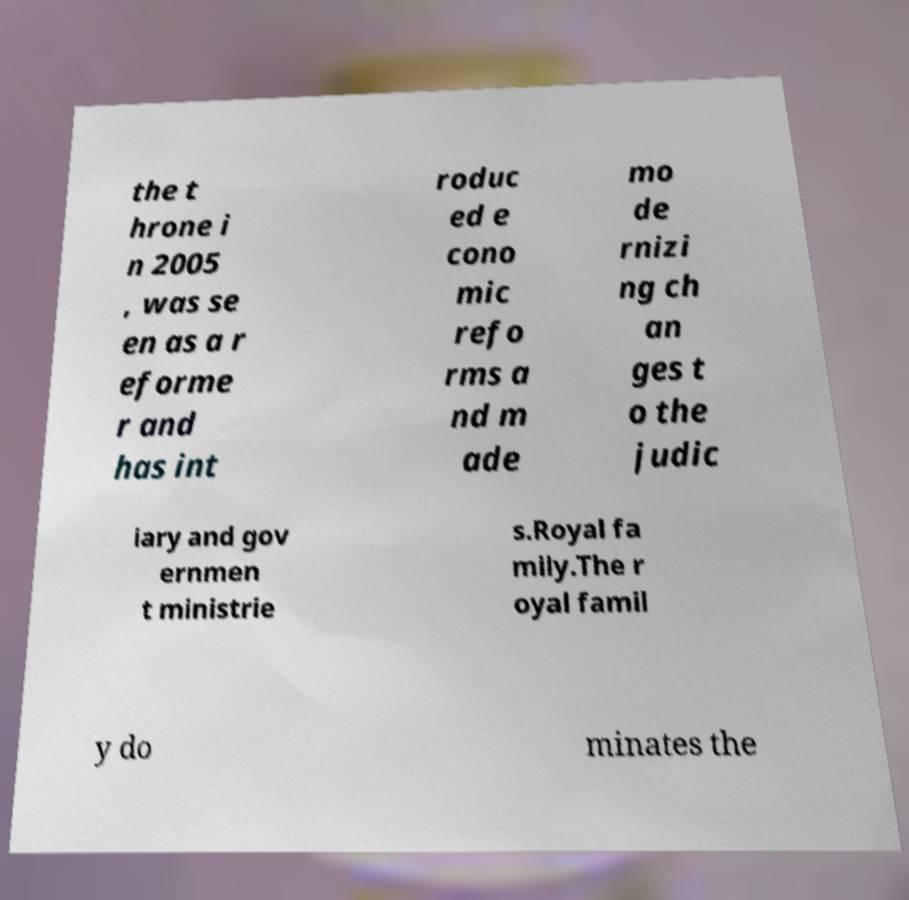Please identify and transcribe the text found in this image. the t hrone i n 2005 , was se en as a r eforme r and has int roduc ed e cono mic refo rms a nd m ade mo de rnizi ng ch an ges t o the judic iary and gov ernmen t ministrie s.Royal fa mily.The r oyal famil y do minates the 